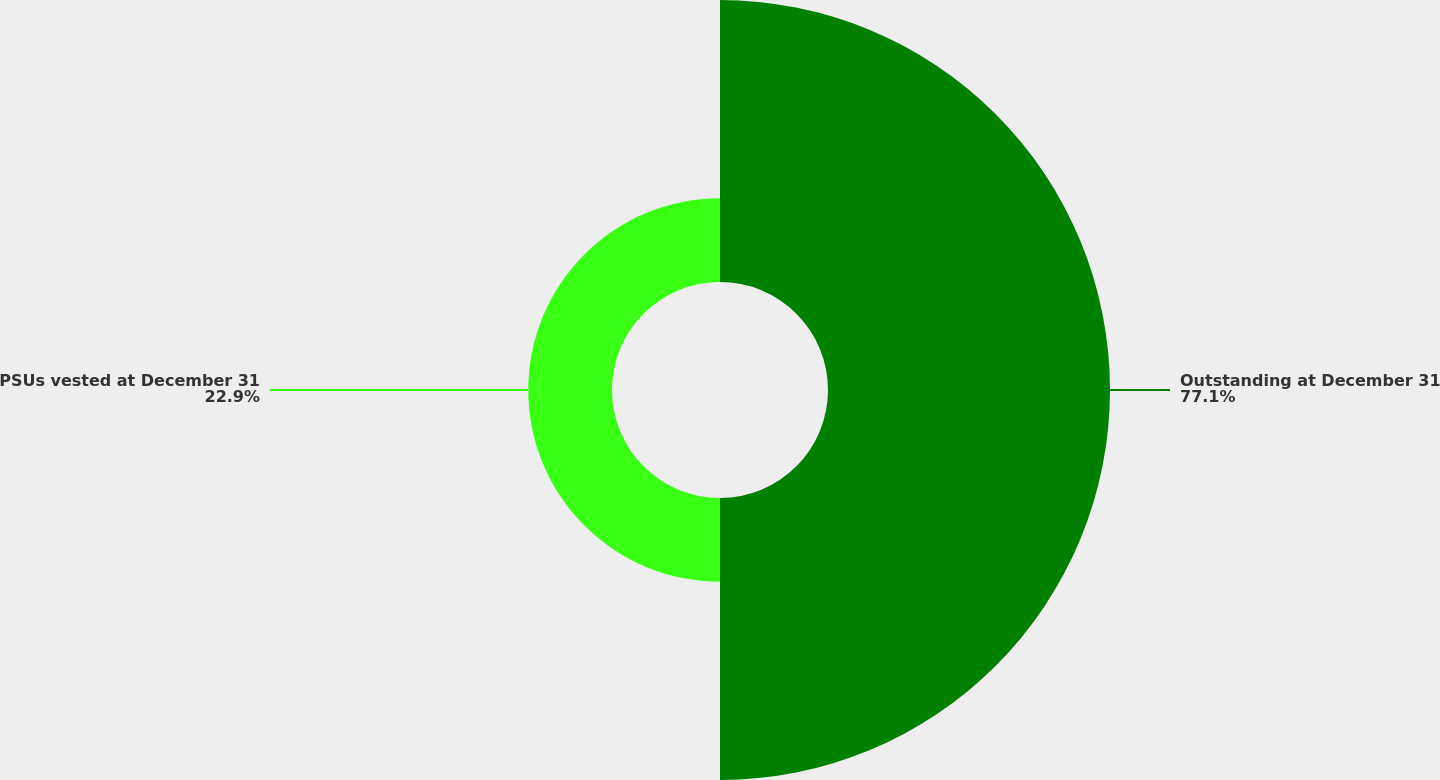Convert chart to OTSL. <chart><loc_0><loc_0><loc_500><loc_500><pie_chart><fcel>Outstanding at December 31<fcel>PSUs vested at December 31<nl><fcel>77.1%<fcel>22.9%<nl></chart> 